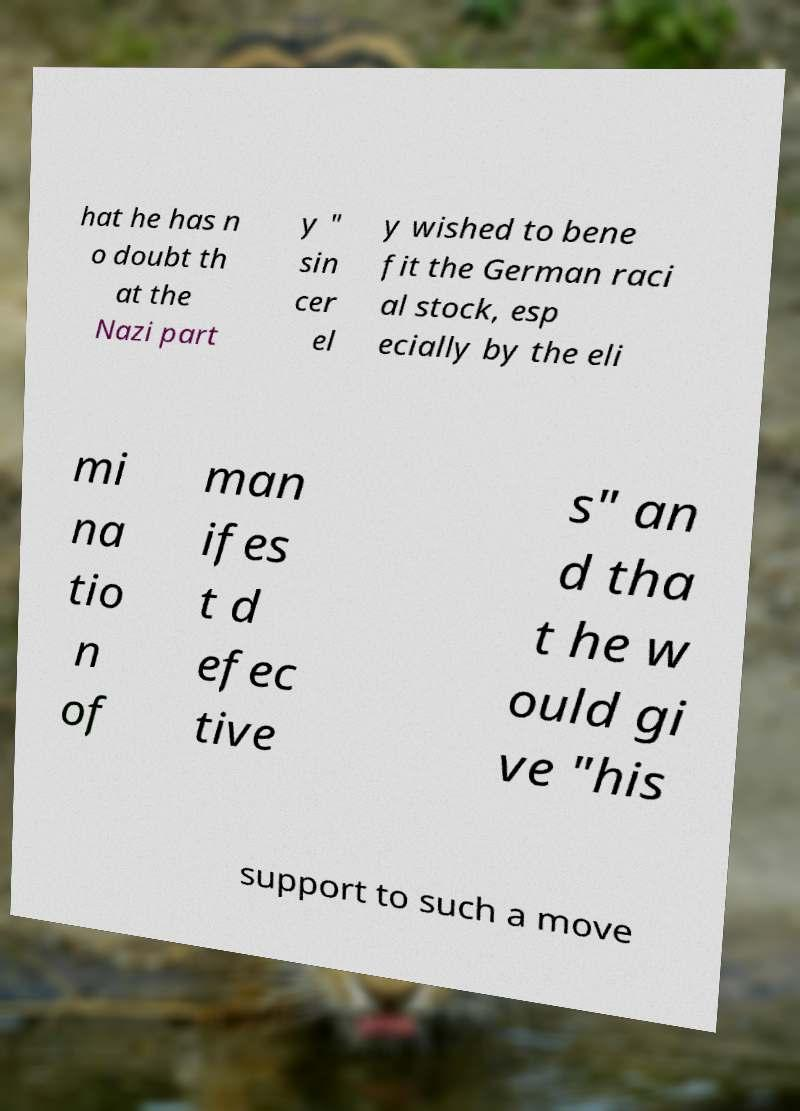I need the written content from this picture converted into text. Can you do that? hat he has n o doubt th at the Nazi part y " sin cer el y wished to bene fit the German raci al stock, esp ecially by the eli mi na tio n of man ifes t d efec tive s" an d tha t he w ould gi ve "his support to such a move 